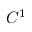<formula> <loc_0><loc_0><loc_500><loc_500>C ^ { 1 }</formula> 